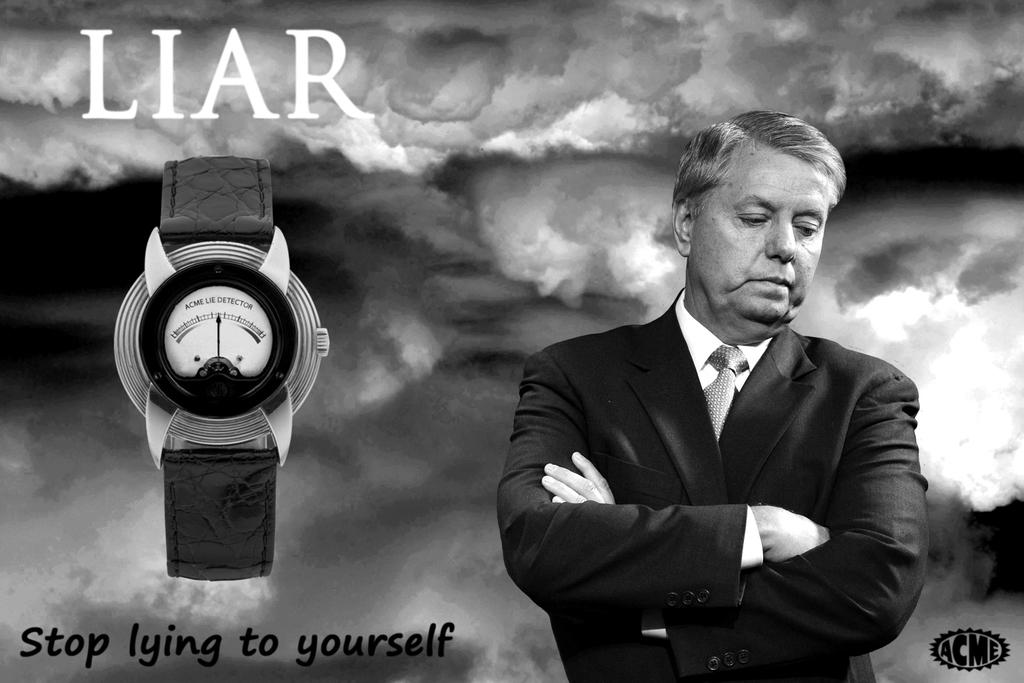<image>
Render a clear and concise summary of the photo. A guy looks sad with a watch next to him and it say Liar. 